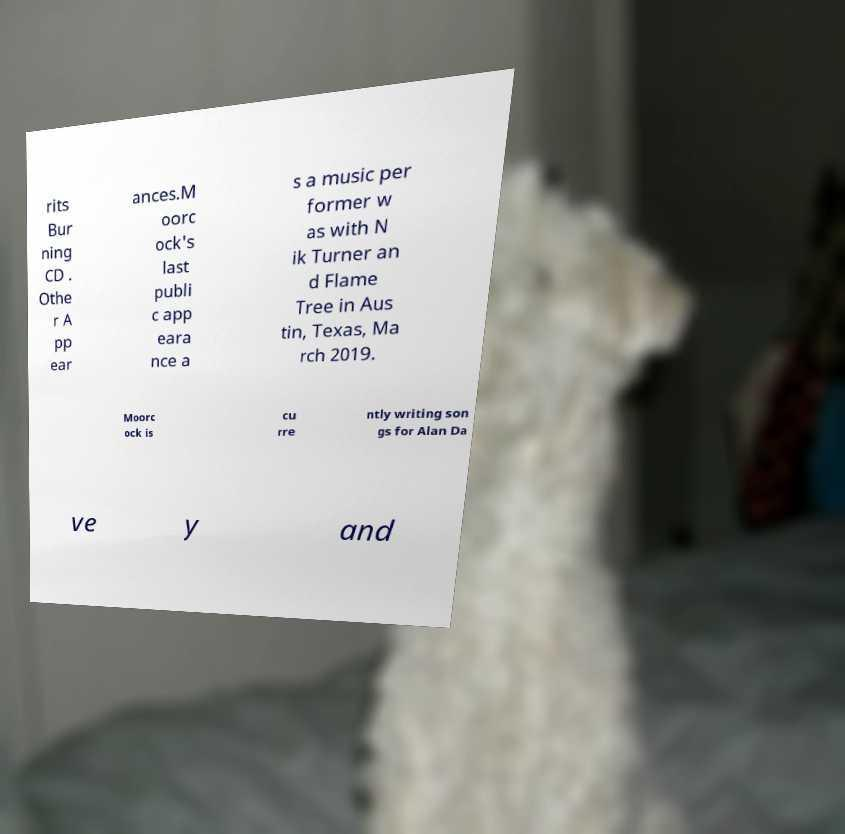There's text embedded in this image that I need extracted. Can you transcribe it verbatim? rits Bur ning CD . Othe r A pp ear ances.M oorc ock's last publi c app eara nce a s a music per former w as with N ik Turner an d Flame Tree in Aus tin, Texas, Ma rch 2019. Moorc ock is cu rre ntly writing son gs for Alan Da ve y and 